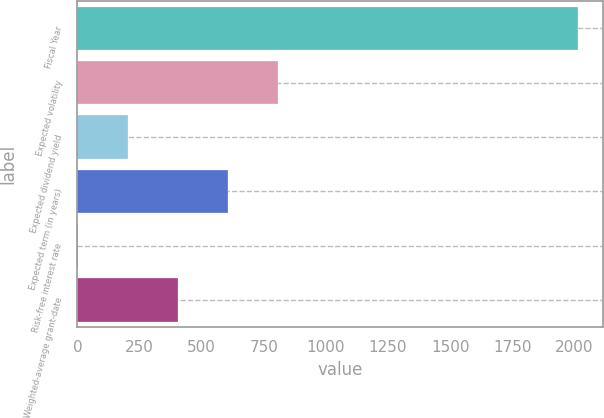Convert chart. <chart><loc_0><loc_0><loc_500><loc_500><bar_chart><fcel>Fiscal Year<fcel>Expected volatility<fcel>Expected dividend yield<fcel>Expected term (in years)<fcel>Risk-free interest rate<fcel>Weighted-average grant-date<nl><fcel>2014<fcel>806.44<fcel>202.66<fcel>605.18<fcel>1.4<fcel>403.92<nl></chart> 